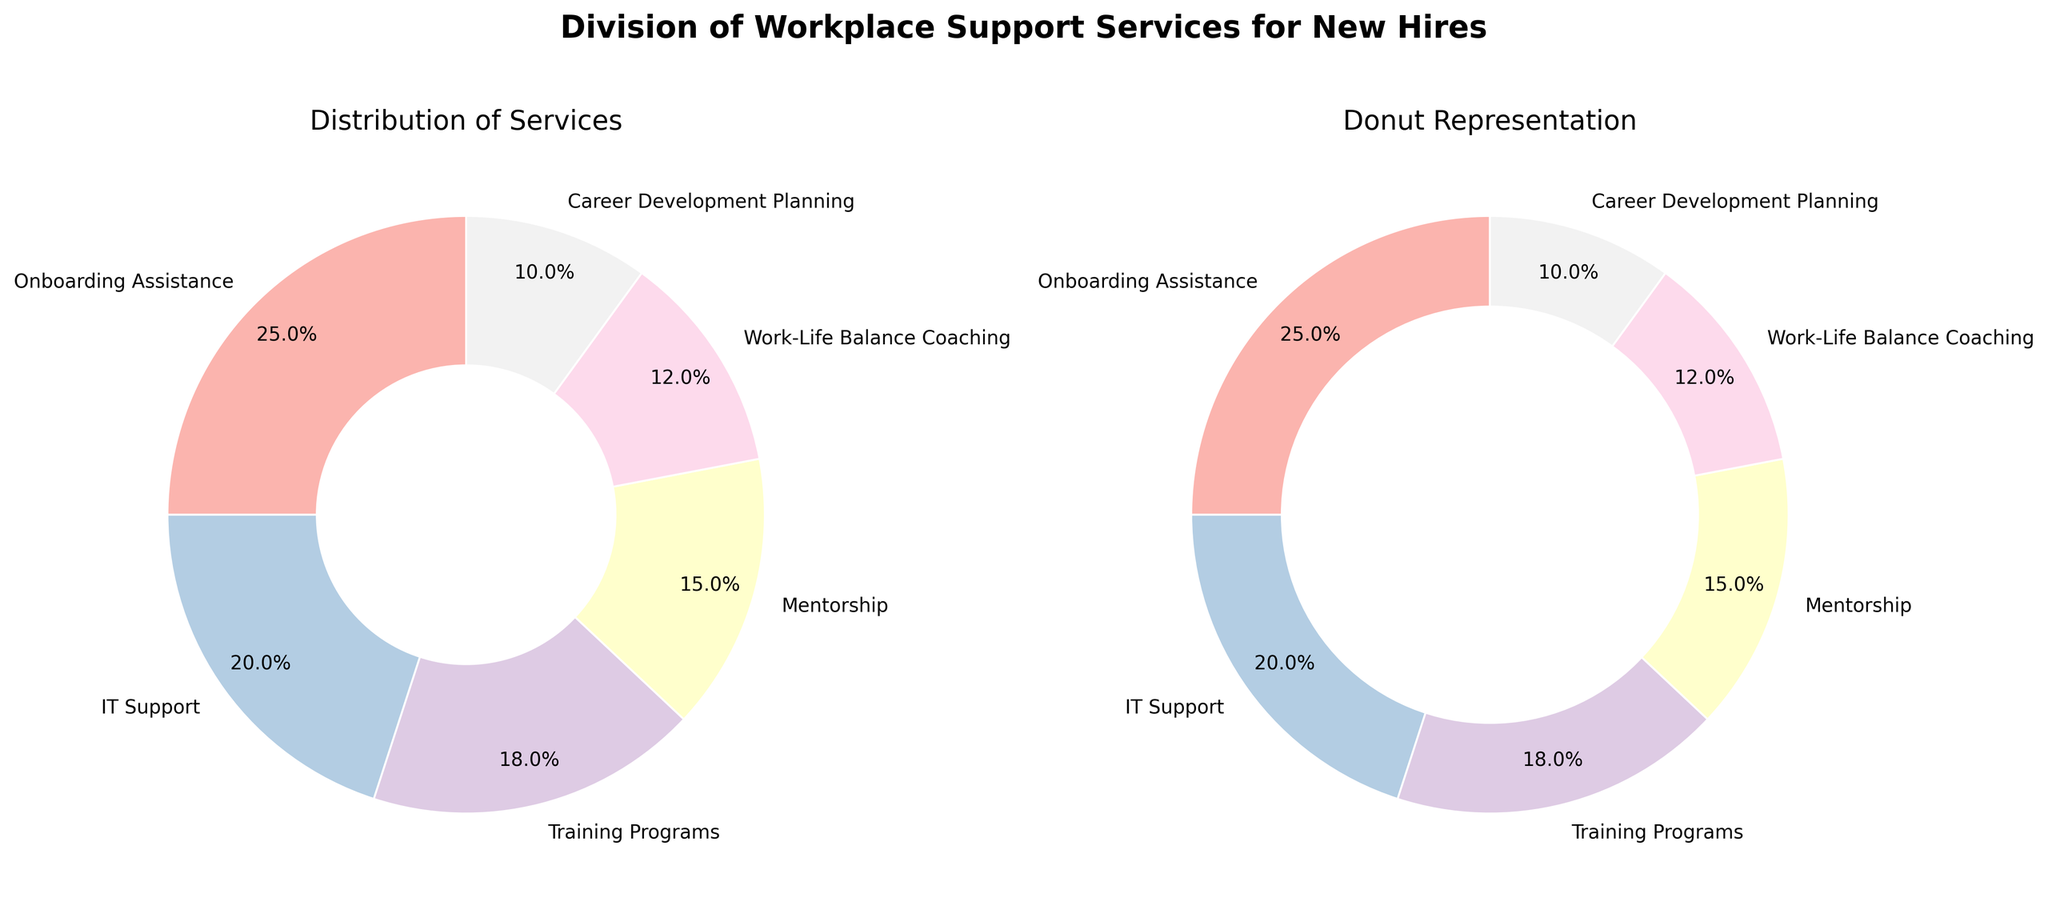Which service type has the highest percentage? To determine the service type with the highest percentage, look at the portion size in the pie chart or donut chart. Onboarding Assistance has the largest segment, indicating it has the highest percentage.
Answer: Onboarding Assistance Which service type has the lowest percentage? To find the lowest percentage, identify the smallest segment in the pie or donut chart. Career Development Planning has the smallest section.
Answer: Career Development Planning What is the combined percentage of IT Support and Training Programs? Sum the percentages of IT Support (20%) and Training Programs (18%). 20 + 18 = 38
Answer: 38% Compare the percentages of Work-Life Balance Coaching and Mentorship. Which is higher? Look at the sizes of the segments for both Work-Life Balance Coaching and Mentorship. Mentorship is larger, meaning it has a higher percentage (15%) compared to Work-Life Balance Coaching (12%).
Answer: Mentorship What is the difference in percentage between the highest and the lowest utilized services? Subtract the percentage of the lowest utilized service (Career Development Planning, 10%) from the highest (Onboarding Assistance, 25%). 25 - 10 = 15
Answer: 15% What is the average percentage utilization of the middle three service types? Add the percentages of the middle three service types (IT Support, Training Programs, and Mentorship) and divide by 3. (20 + 18 + 15) / 3 = 53 / 3 ≈ 17.67
Answer: 17.67% What is the total percentage of services used for training-related purposes? Sum the percentages for Training Programs and Career Development Planning. 18 + 10 = 28
Answer: 28% Which segment appears closest to the start angle (90 degrees) in the pie charts? Observing the charts, the segment starting closest to 90 degrees appears to be Onboarding Assistance, based on the layout.
Answer: Onboarding Assistance Which service appears directly opposite to Career Development Planning in the pie charts? Visually trace the location of Career Development Planning and find the segment directly across the chart. It's Onboarding Assistance.
Answer: Onboarding Assistance 